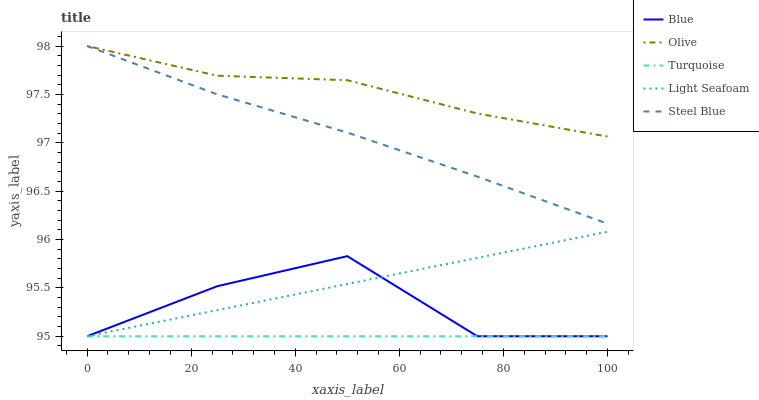Does Turquoise have the minimum area under the curve?
Answer yes or no. Yes. Does Olive have the maximum area under the curve?
Answer yes or no. Yes. Does Olive have the minimum area under the curve?
Answer yes or no. No. Does Turquoise have the maximum area under the curve?
Answer yes or no. No. Is Turquoise the smoothest?
Answer yes or no. Yes. Is Blue the roughest?
Answer yes or no. Yes. Is Olive the smoothest?
Answer yes or no. No. Is Olive the roughest?
Answer yes or no. No. Does Blue have the lowest value?
Answer yes or no. Yes. Does Olive have the lowest value?
Answer yes or no. No. Does Steel Blue have the highest value?
Answer yes or no. Yes. Does Turquoise have the highest value?
Answer yes or no. No. Is Light Seafoam less than Steel Blue?
Answer yes or no. Yes. Is Olive greater than Blue?
Answer yes or no. Yes. Does Turquoise intersect Light Seafoam?
Answer yes or no. Yes. Is Turquoise less than Light Seafoam?
Answer yes or no. No. Is Turquoise greater than Light Seafoam?
Answer yes or no. No. Does Light Seafoam intersect Steel Blue?
Answer yes or no. No. 